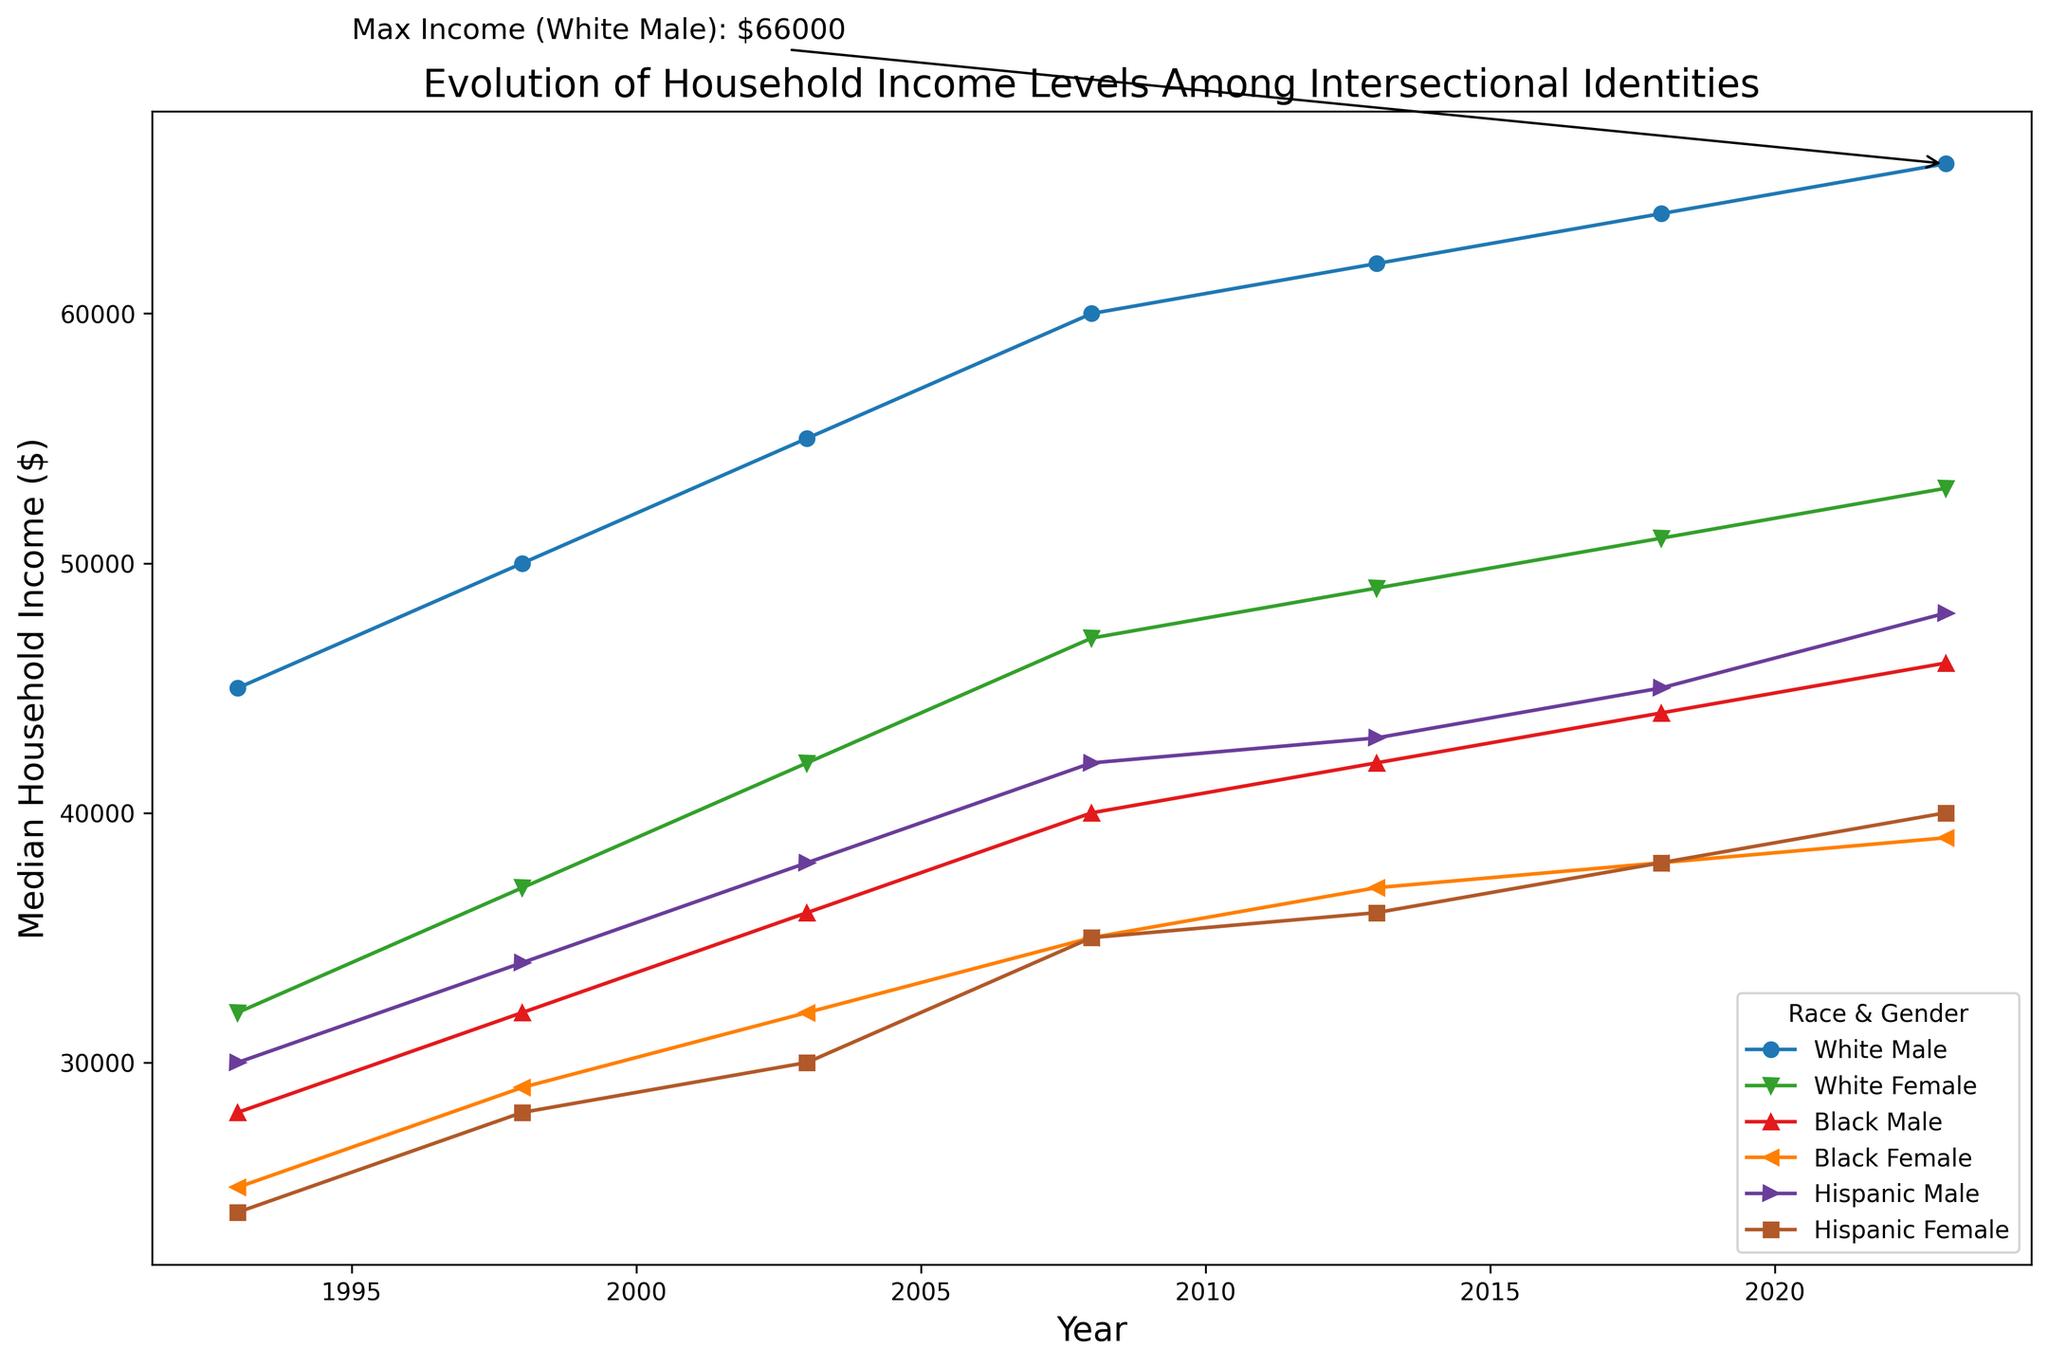What is the highest median household income recorded in the chart? The annotation indicates that the maximum median household income for White Males is $66,000, achieved in 2023.
Answer: $66,000 Which group had the lowest median household income in 1993? Looking at the data points for 1993, Hispanic Females had the lowest median household income at $24,000.
Answer: Hispanic Females How has the median household income for Black Females changed from 1993 to 2023? In 1993, the median household income for Black Females was $25,000, and in 2023, it is $39,000. The change is $39,000 - $25,000 = $14,000.
Answer: Increased by $14,000 Which group showed the greatest increase in median household income between 1993 and 2023? Comparing all the groups, White Males increased from $45,000 in 1993 to $66,000 in 2023, an increase of $21,000. This is the largest increase noted in the dataset.
Answer: White Males What was the median household income for Hispanic Males in 2008? Locate the data points for 2008; Hispanic Males had a median household income of $42,000.
Answer: $42,000 Between which years did White Females experience the highest increase in median household income? Analyzing the data points, White Females' median household income increased from $37,000 in 1998 to $42,000 in 2003—the highest point increase of $5,000 in a given period.
Answer: 1998 to 2003 By how much did the median household income for Black Males differ from Hispanic Females in 2023? In 2023, the median household income for Black Males was $46,000, while for Hispanic Females, it was $40,000. The difference is $46,000 - $40,000 = $6,000.
Answer: $6,000 On the graph, what color represents the data for White Females? The line for White Females is represented in green.
Answer: Green 